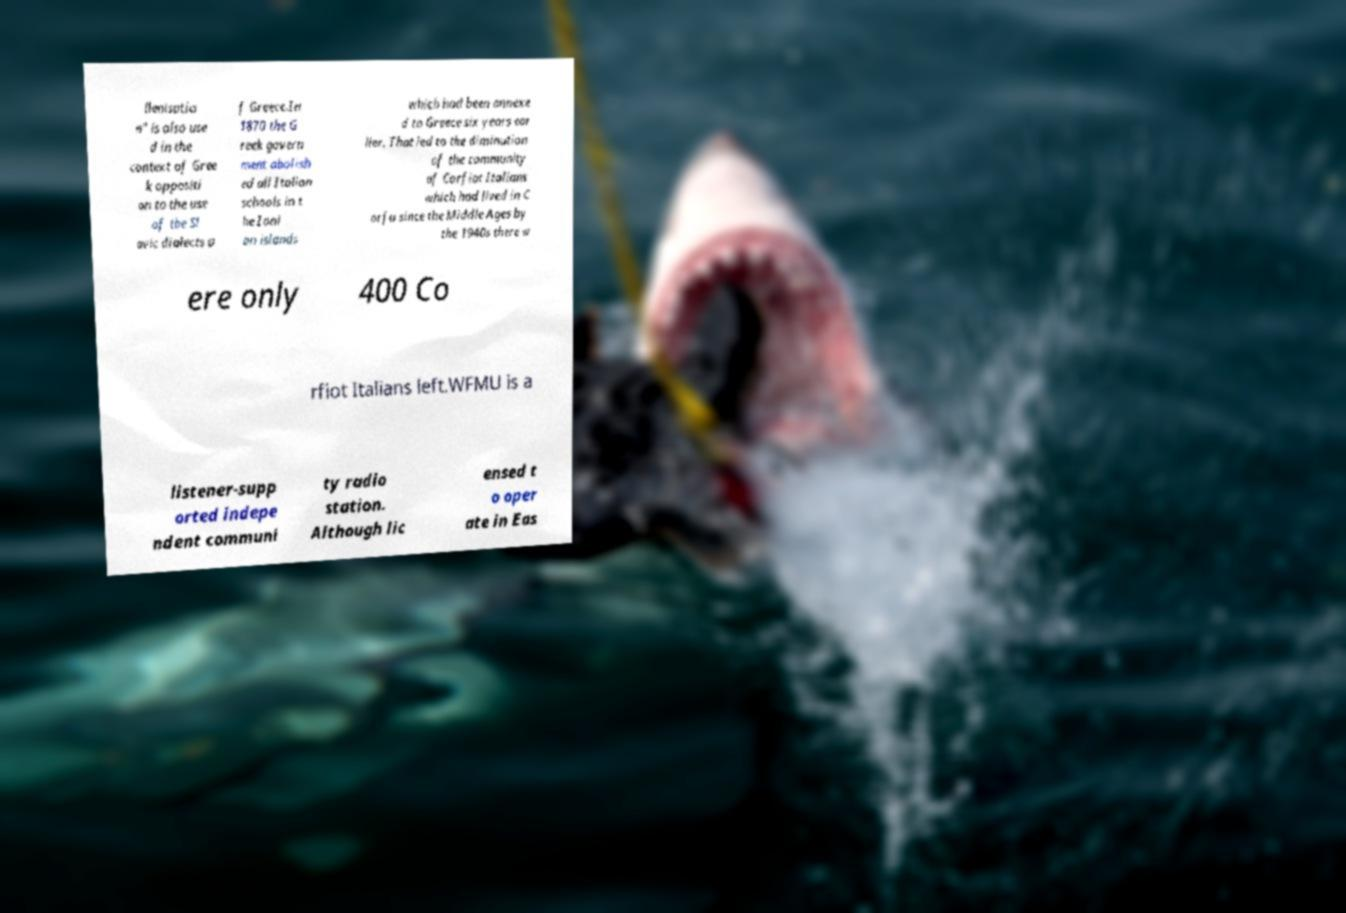I need the written content from this picture converted into text. Can you do that? llenisatio n" is also use d in the context of Gree k oppositi on to the use of the Sl avic dialects o f Greece.In 1870 the G reek govern ment abolish ed all Italian schools in t he Ioni an islands which had been annexe d to Greece six years ear lier. That led to the diminution of the community of Corfiot Italians which had lived in C orfu since the Middle Ages by the 1940s there w ere only 400 Co rfiot Italians left.WFMU is a listener-supp orted indepe ndent communi ty radio station. Although lic ensed t o oper ate in Eas 